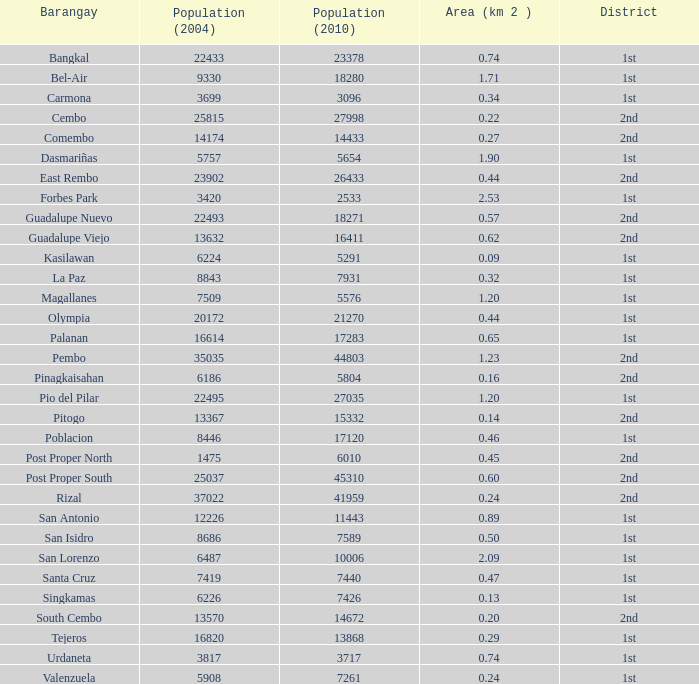What is the location where the barangay is guadalupe viejo? 0.62. 